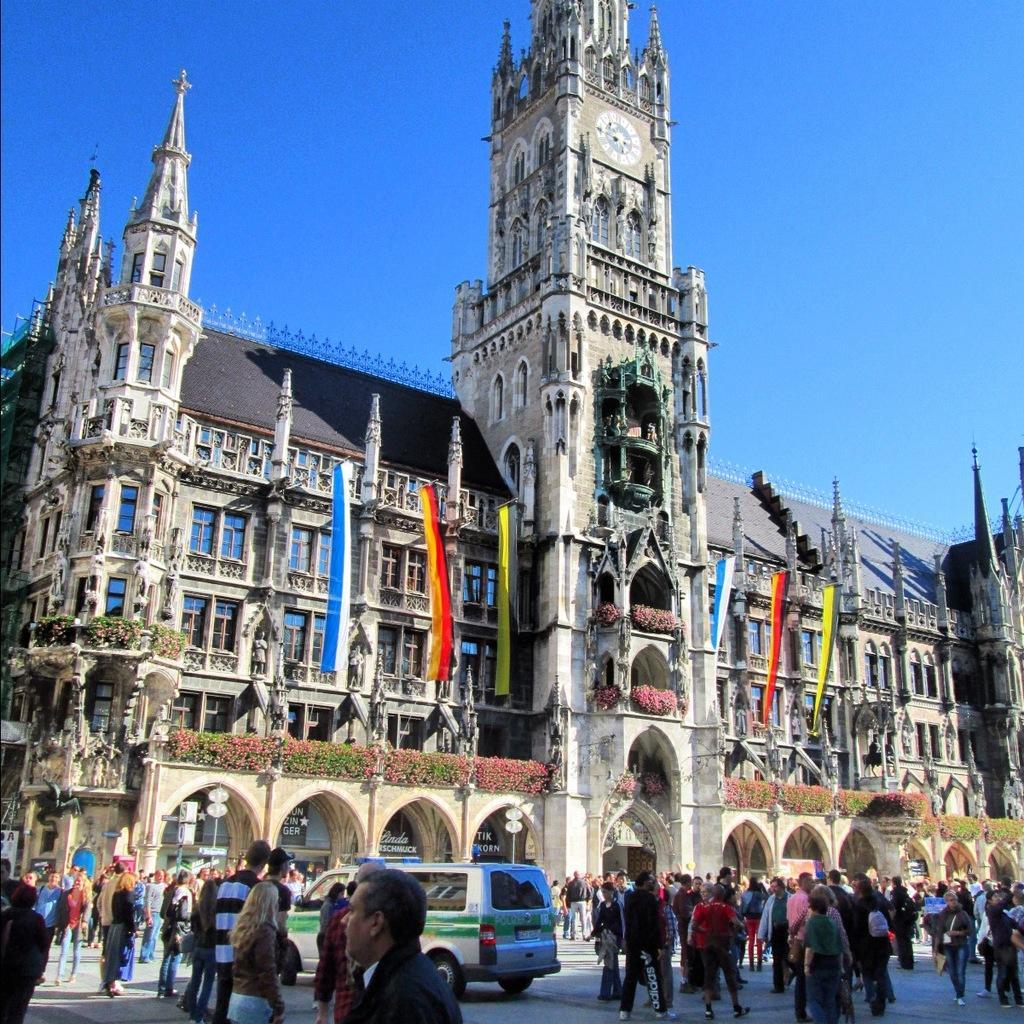Describe this image in one or two sentences. This is an outside view. At the bottom of the image I can see a crowd of people on the ground and also there is a vehicle. In the middle of the image there is a building and I can see few flags. At the top of the image I can see the sky. 